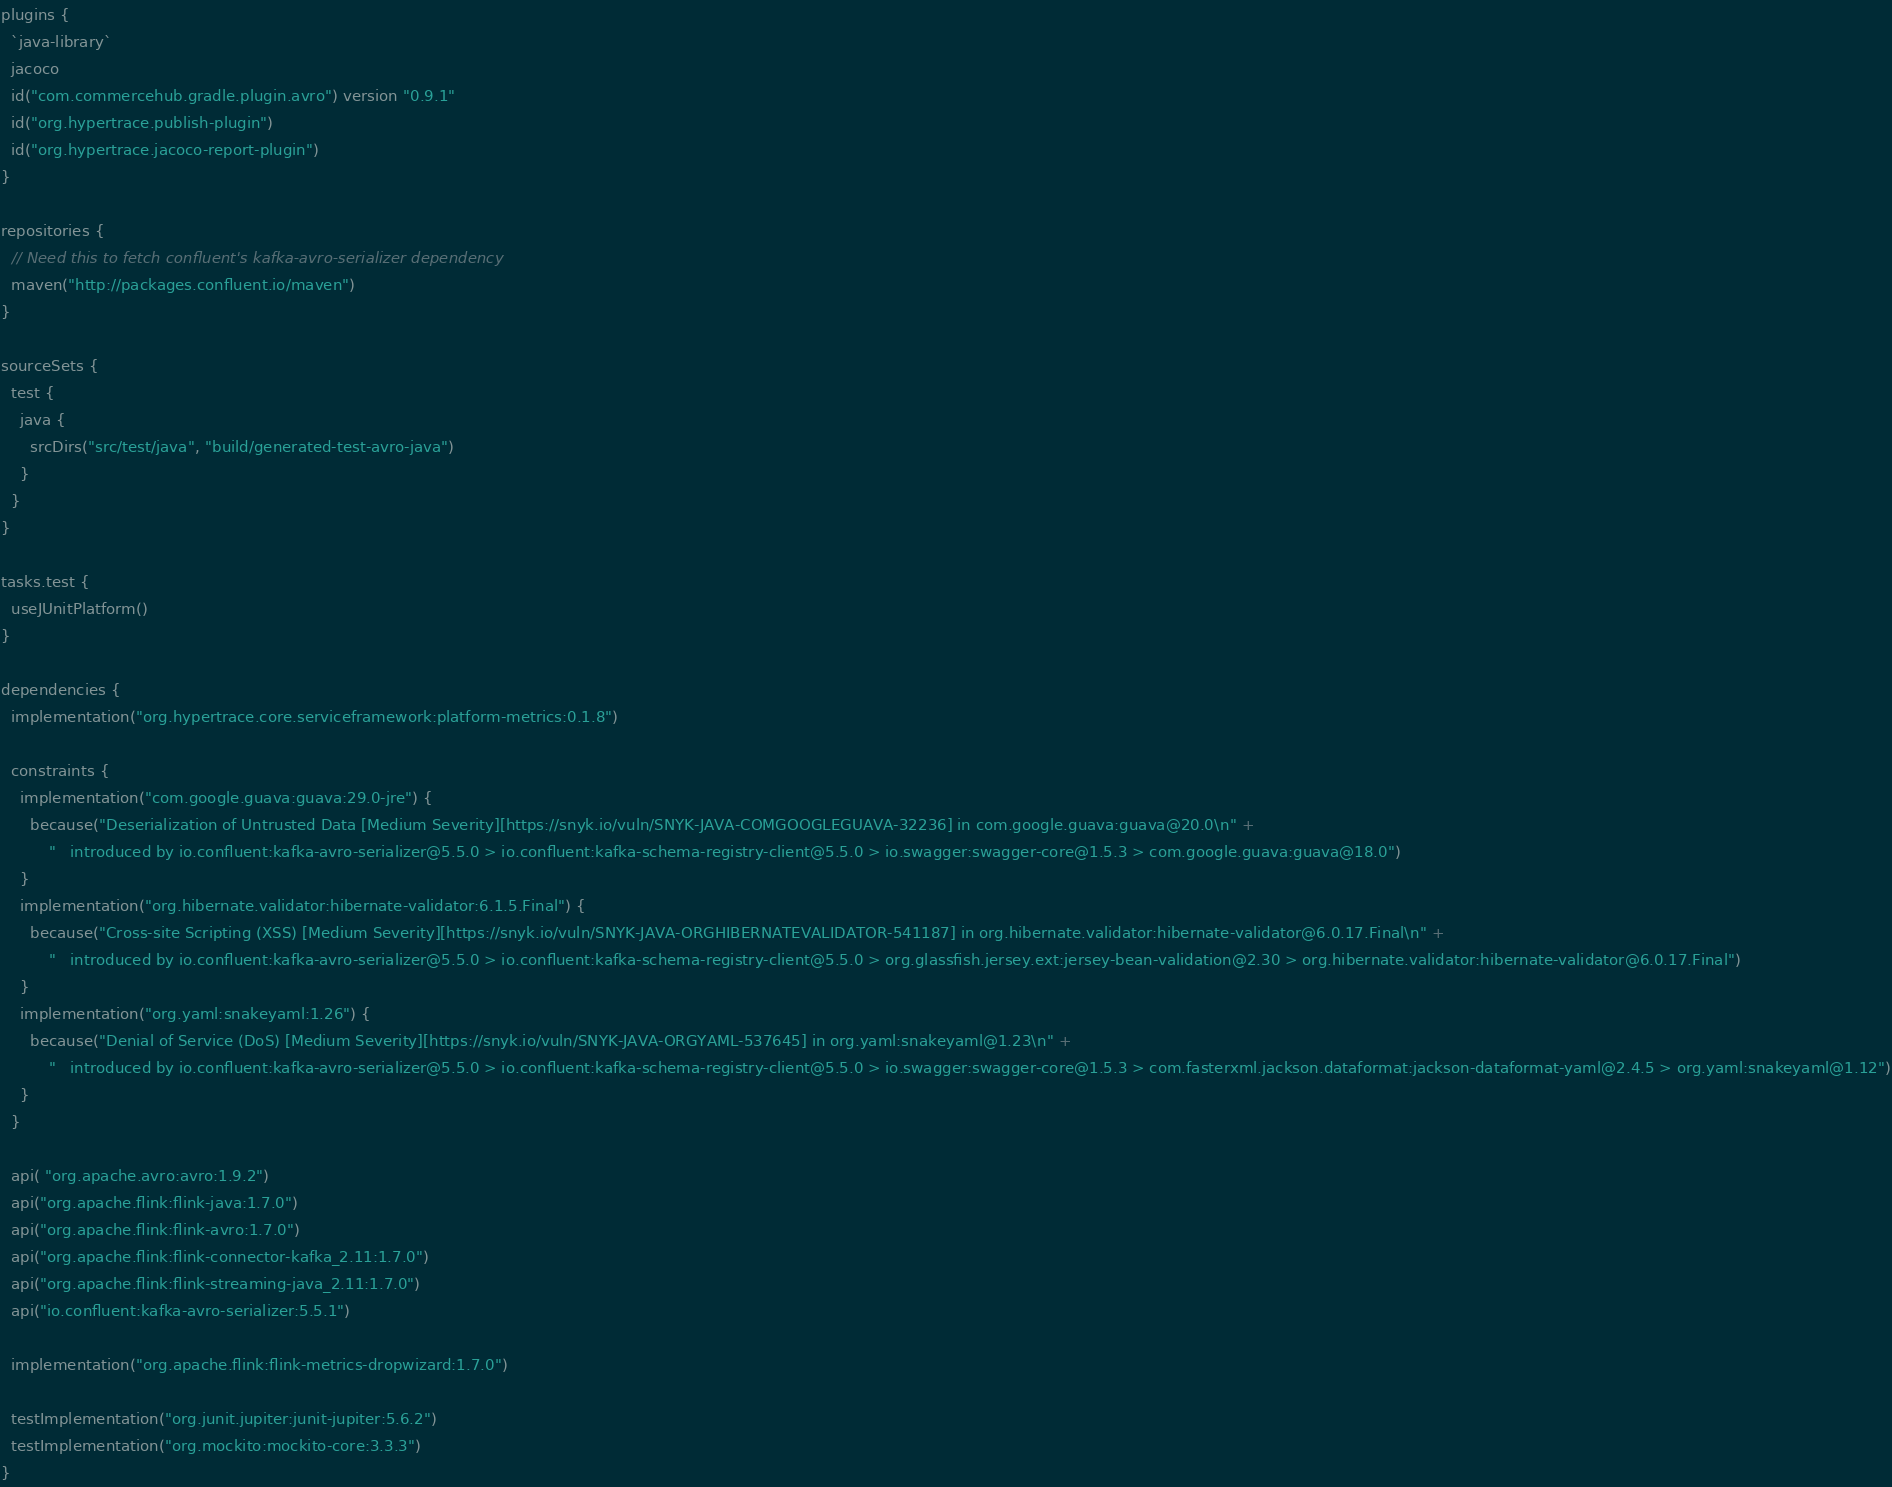<code> <loc_0><loc_0><loc_500><loc_500><_Kotlin_>plugins {
  `java-library`
  jacoco
  id("com.commercehub.gradle.plugin.avro") version "0.9.1"
  id("org.hypertrace.publish-plugin")
  id("org.hypertrace.jacoco-report-plugin")
}

repositories {
  // Need this to fetch confluent's kafka-avro-serializer dependency
  maven("http://packages.confluent.io/maven")
}

sourceSets {
  test {
    java {
      srcDirs("src/test/java", "build/generated-test-avro-java")
    }
  }
}

tasks.test {
  useJUnitPlatform()
}

dependencies {
  implementation("org.hypertrace.core.serviceframework:platform-metrics:0.1.8")

  constraints {
    implementation("com.google.guava:guava:29.0-jre") {
      because("Deserialization of Untrusted Data [Medium Severity][https://snyk.io/vuln/SNYK-JAVA-COMGOOGLEGUAVA-32236] in com.google.guava:guava@20.0\n" +
          "   introduced by io.confluent:kafka-avro-serializer@5.5.0 > io.confluent:kafka-schema-registry-client@5.5.0 > io.swagger:swagger-core@1.5.3 > com.google.guava:guava@18.0")
    }
    implementation("org.hibernate.validator:hibernate-validator:6.1.5.Final") {
      because("Cross-site Scripting (XSS) [Medium Severity][https://snyk.io/vuln/SNYK-JAVA-ORGHIBERNATEVALIDATOR-541187] in org.hibernate.validator:hibernate-validator@6.0.17.Final\n" +
          "   introduced by io.confluent:kafka-avro-serializer@5.5.0 > io.confluent:kafka-schema-registry-client@5.5.0 > org.glassfish.jersey.ext:jersey-bean-validation@2.30 > org.hibernate.validator:hibernate-validator@6.0.17.Final")
    }
    implementation("org.yaml:snakeyaml:1.26") {
      because("Denial of Service (DoS) [Medium Severity][https://snyk.io/vuln/SNYK-JAVA-ORGYAML-537645] in org.yaml:snakeyaml@1.23\n" +
          "   introduced by io.confluent:kafka-avro-serializer@5.5.0 > io.confluent:kafka-schema-registry-client@5.5.0 > io.swagger:swagger-core@1.5.3 > com.fasterxml.jackson.dataformat:jackson-dataformat-yaml@2.4.5 > org.yaml:snakeyaml@1.12")
    }
  }

  api( "org.apache.avro:avro:1.9.2")
  api("org.apache.flink:flink-java:1.7.0")
  api("org.apache.flink:flink-avro:1.7.0")
  api("org.apache.flink:flink-connector-kafka_2.11:1.7.0")
  api("org.apache.flink:flink-streaming-java_2.11:1.7.0")
  api("io.confluent:kafka-avro-serializer:5.5.1")

  implementation("org.apache.flink:flink-metrics-dropwizard:1.7.0")

  testImplementation("org.junit.jupiter:junit-jupiter:5.6.2")
  testImplementation("org.mockito:mockito-core:3.3.3")
}
</code> 